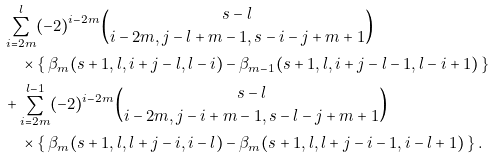Convert formula to latex. <formula><loc_0><loc_0><loc_500><loc_500>& \sum _ { i = 2 m } ^ { l } ( - 2 ) ^ { i - 2 m } \binom { s - l } { i - 2 m , j - l + m - 1 , s - i - j + m + 1 } \\ & \quad \times \left \{ \, \beta _ { m } ( s + 1 , l , i + j - l , l - i ) - \beta _ { m - 1 } ( s + 1 , l , i + j - l - 1 , l - i + 1 ) \, \right \} \\ & + \sum _ { i = 2 m } ^ { l - 1 } ( - 2 ) ^ { i - 2 m } \binom { s - l } { i - 2 m , j - i + m - 1 , s - l - j + m + 1 } \\ & \quad \times \left \{ \, \beta _ { m } ( s + 1 , l , l + j - i , i - l ) - \beta _ { m } ( s + 1 , l , l + j - i - 1 , i - l + 1 ) \, \right \} .</formula> 